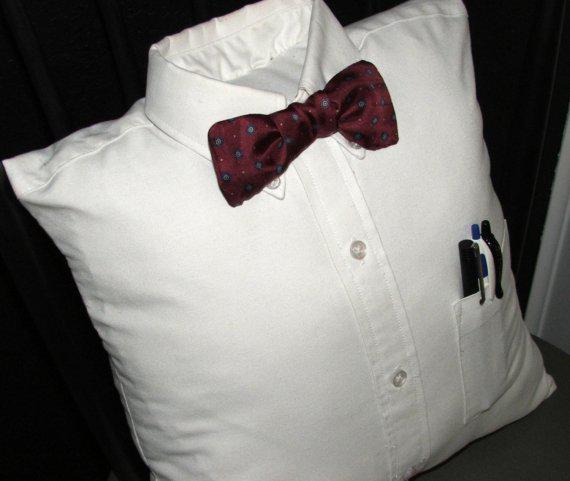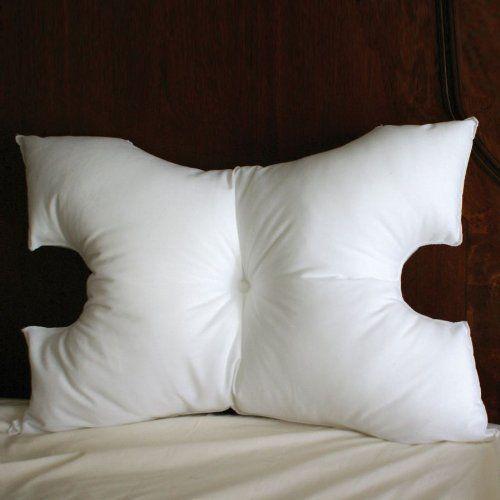The first image is the image on the left, the second image is the image on the right. Examine the images to the left and right. Is the description "There are at least six pillows in the image on the right" accurate? Answer yes or no. No. The first image is the image on the left, the second image is the image on the right. For the images displayed, is the sentence "A image shows a pillow with a 3D embellishment." factually correct? Answer yes or no. Yes. 